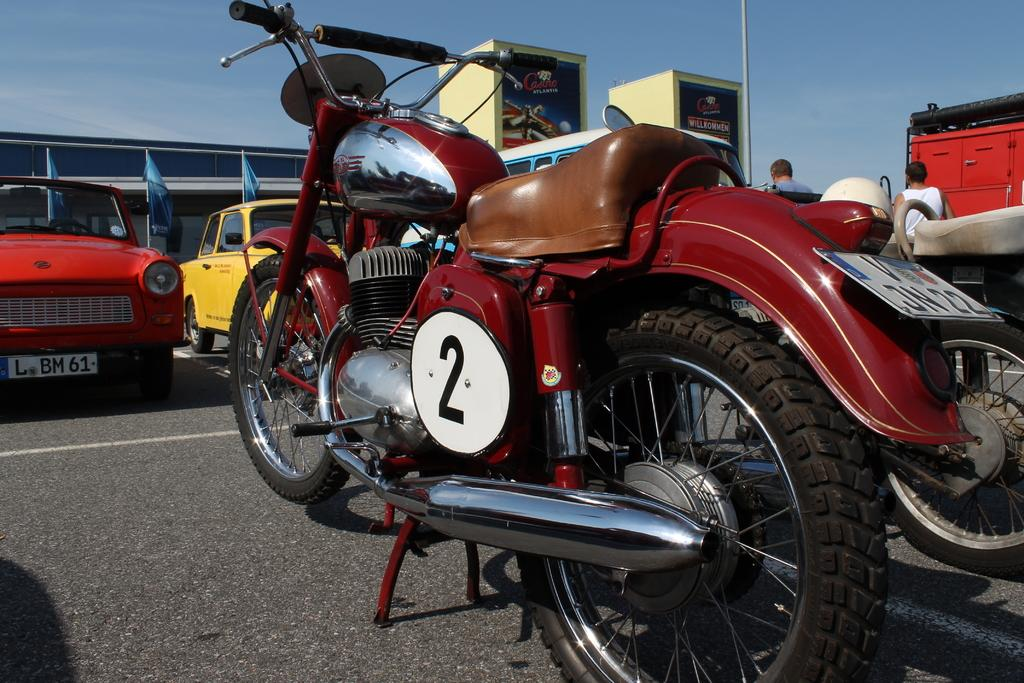<image>
Relay a brief, clear account of the picture shown. A vintage motorcycle has a number 2 placard on its side. 